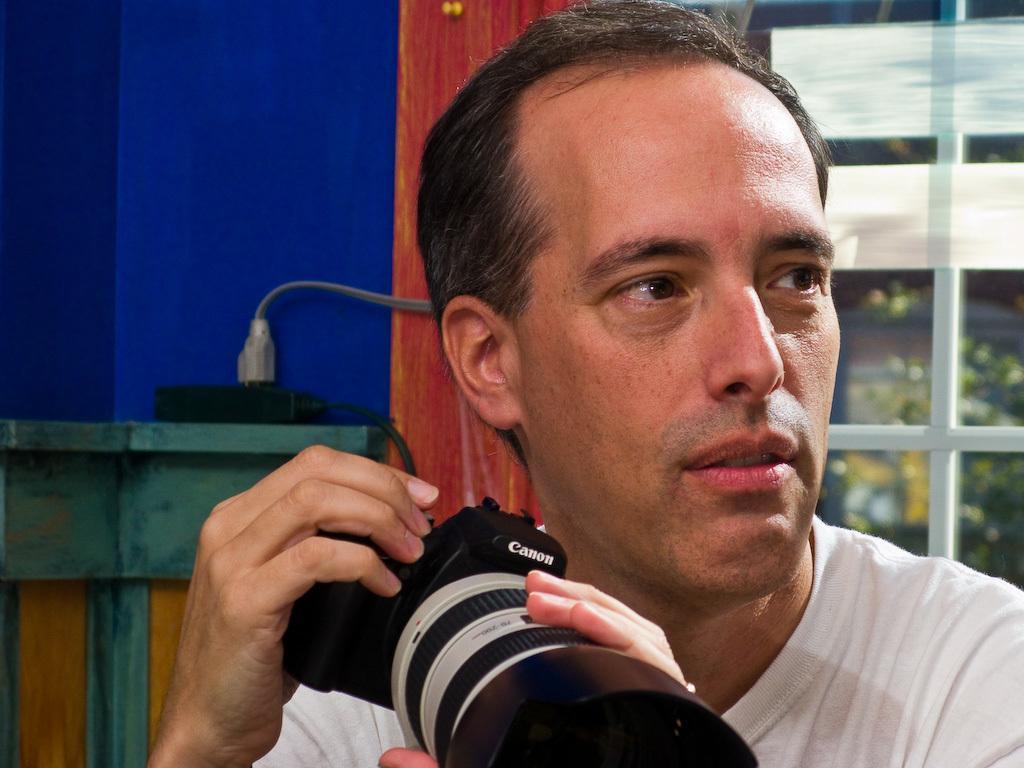How would you summarize this image in a sentence or two? He is holding a camera. We can see in background window and trees. 